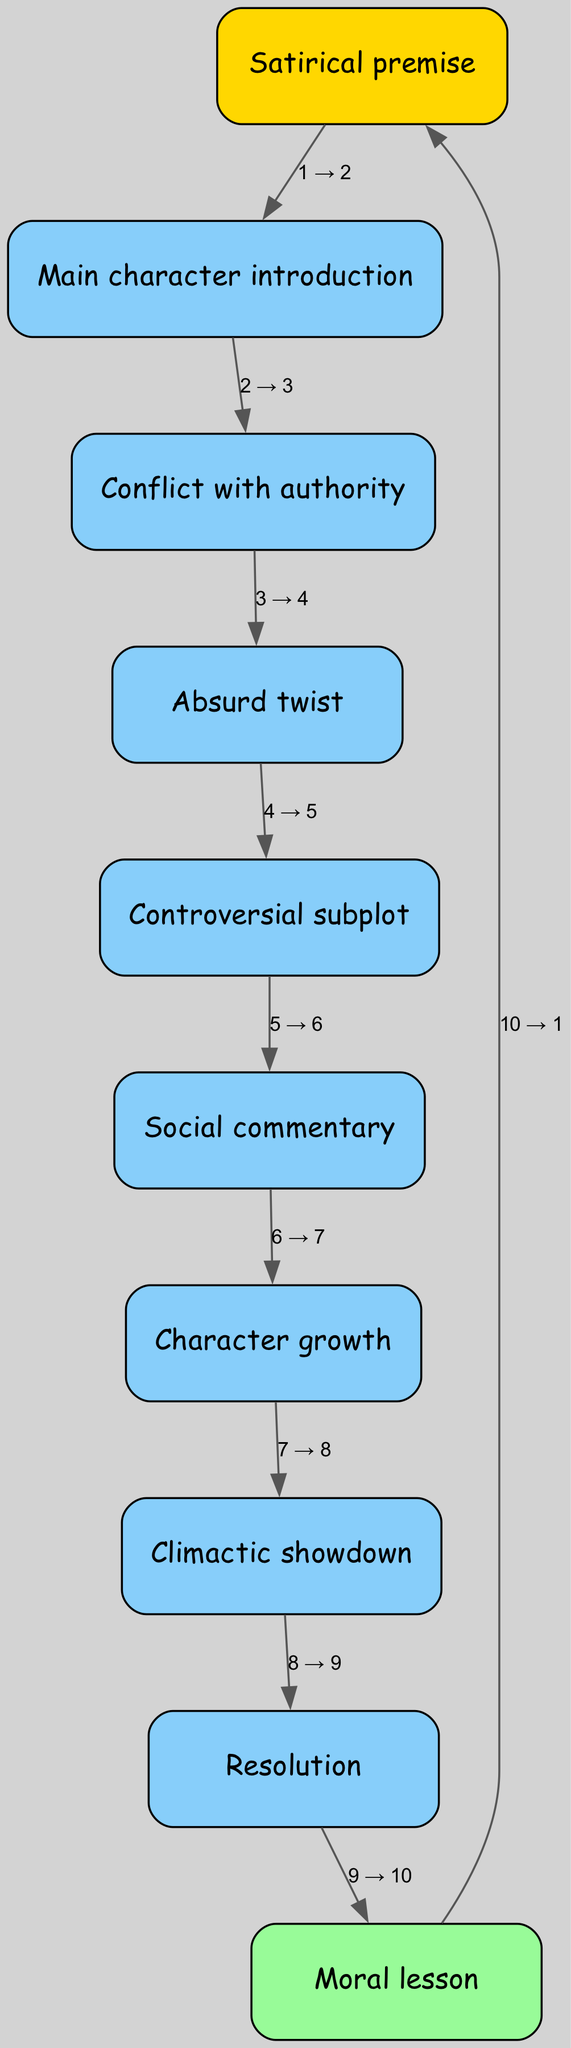What is the first node in the diagram? The first node in the diagram is "Satirical premise", which is typically where a story begins and sets the tone for the narrative.
Answer: Satirical premise How many nodes are present in the diagram? There are ten nodes listed in the diagram, representing different stages of the plot structure.
Answer: 10 What node comes immediately after "Absurd twist"? After the "Absurd twist", the diagram shows "Controversial subplot" as the next node. This follows the flow of the story presented in the graph.
Answer: Controversial subplot What is the last node before returning to the start? The last node before returning to the start is "Moral lesson", which loops back to "Satirical premise," indicating a cyclical nature of the story.
Answer: Moral lesson Identify the two nodes directly connected to "Character growth". "Character growth" is directly connected to "Social commentary" and "Climactic showdown", showing the progression of character development leading into a significant confrontation.
Answer: Social commentary, Climactic showdown What is the relationship between "Conflict with authority" and "Absurd twist"? "Conflict with authority" directly leads to "Absurd twist", indicating that the development of conflict results in an unexpected event that shapes the narrative.
Answer: Directly leads to Which node indicates a turning point in the story? "Climactic showdown" is the node that represents a major turning point, often where the primary conflicts reach their peak and require resolution.
Answer: Climactic showdown How many edges are there connecting different nodes? There are nine edges in the diagram, each representing connections between various nodes that illustrate the story's progression.
Answer: 9 What node follows "Resolution" in the graph? After "Resolution", the next node is "Moral lesson", indicating that this part of the plot reflects on the outcomes of the preceding events.
Answer: Moral lesson Which node serves as a commentary on society? "Social commentary" serves as a critical reflection on societal issues within the structure of the plot, building off previous developments.
Answer: Social commentary 